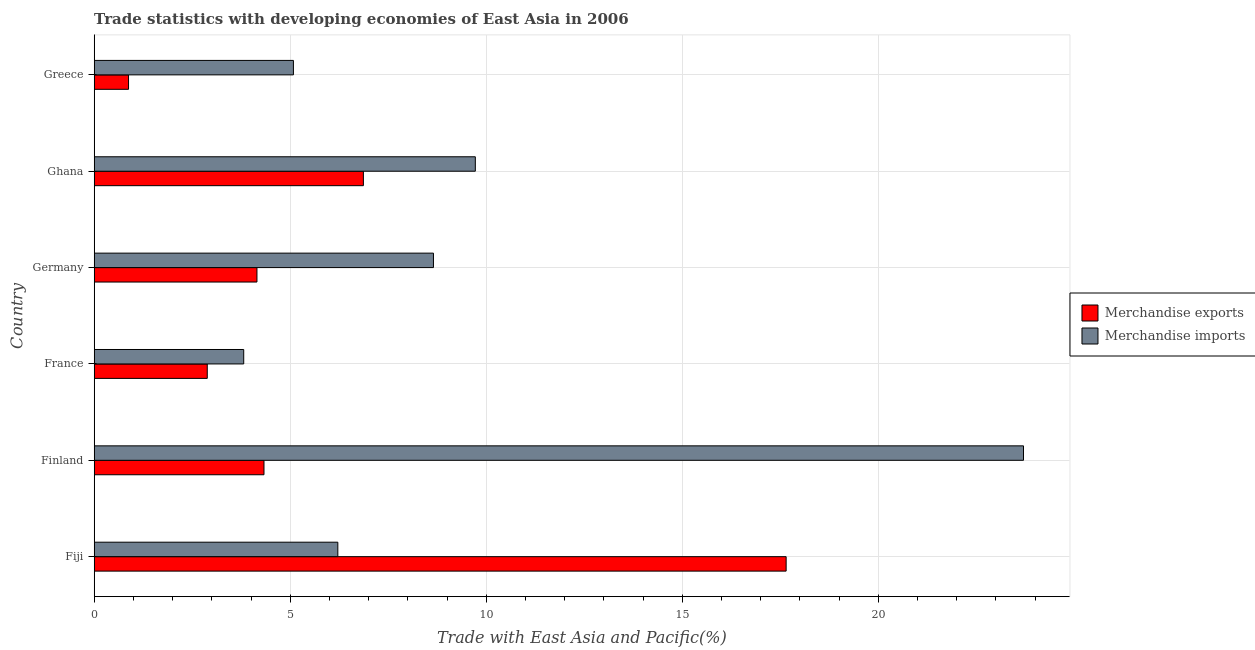How many different coloured bars are there?
Ensure brevity in your answer.  2. How many groups of bars are there?
Provide a succinct answer. 6. Are the number of bars per tick equal to the number of legend labels?
Give a very brief answer. Yes. Are the number of bars on each tick of the Y-axis equal?
Keep it short and to the point. Yes. What is the label of the 6th group of bars from the top?
Keep it short and to the point. Fiji. What is the merchandise exports in Germany?
Offer a very short reply. 4.15. Across all countries, what is the maximum merchandise exports?
Provide a short and direct response. 17.65. Across all countries, what is the minimum merchandise exports?
Provide a short and direct response. 0.88. In which country was the merchandise imports maximum?
Your answer should be compact. Finland. In which country was the merchandise imports minimum?
Your answer should be very brief. France. What is the total merchandise imports in the graph?
Keep it short and to the point. 57.18. What is the difference between the merchandise imports in Fiji and that in Finland?
Offer a terse response. -17.49. What is the difference between the merchandise exports in Finland and the merchandise imports in France?
Give a very brief answer. 0.52. What is the average merchandise exports per country?
Offer a very short reply. 6.13. What is the difference between the merchandise imports and merchandise exports in Greece?
Your answer should be very brief. 4.21. What is the ratio of the merchandise imports in France to that in Ghana?
Give a very brief answer. 0.39. Is the difference between the merchandise exports in Fiji and Germany greater than the difference between the merchandise imports in Fiji and Germany?
Your answer should be compact. Yes. What is the difference between the highest and the second highest merchandise imports?
Keep it short and to the point. 13.98. What is the difference between the highest and the lowest merchandise exports?
Ensure brevity in your answer.  16.77. In how many countries, is the merchandise imports greater than the average merchandise imports taken over all countries?
Your answer should be very brief. 2. Is the sum of the merchandise imports in Fiji and Finland greater than the maximum merchandise exports across all countries?
Give a very brief answer. Yes. How many bars are there?
Your answer should be very brief. 12. Are all the bars in the graph horizontal?
Your answer should be compact. Yes. Are the values on the major ticks of X-axis written in scientific E-notation?
Offer a terse response. No. Does the graph contain any zero values?
Your response must be concise. No. How many legend labels are there?
Offer a terse response. 2. How are the legend labels stacked?
Offer a very short reply. Vertical. What is the title of the graph?
Give a very brief answer. Trade statistics with developing economies of East Asia in 2006. What is the label or title of the X-axis?
Give a very brief answer. Trade with East Asia and Pacific(%). What is the label or title of the Y-axis?
Your answer should be compact. Country. What is the Trade with East Asia and Pacific(%) of Merchandise exports in Fiji?
Give a very brief answer. 17.65. What is the Trade with East Asia and Pacific(%) in Merchandise imports in Fiji?
Make the answer very short. 6.21. What is the Trade with East Asia and Pacific(%) in Merchandise exports in Finland?
Keep it short and to the point. 4.33. What is the Trade with East Asia and Pacific(%) of Merchandise imports in Finland?
Ensure brevity in your answer.  23.7. What is the Trade with East Asia and Pacific(%) of Merchandise exports in France?
Keep it short and to the point. 2.88. What is the Trade with East Asia and Pacific(%) of Merchandise imports in France?
Give a very brief answer. 3.81. What is the Trade with East Asia and Pacific(%) of Merchandise exports in Germany?
Provide a succinct answer. 4.15. What is the Trade with East Asia and Pacific(%) of Merchandise imports in Germany?
Make the answer very short. 8.65. What is the Trade with East Asia and Pacific(%) in Merchandise exports in Ghana?
Give a very brief answer. 6.87. What is the Trade with East Asia and Pacific(%) in Merchandise imports in Ghana?
Provide a short and direct response. 9.72. What is the Trade with East Asia and Pacific(%) in Merchandise exports in Greece?
Offer a terse response. 0.88. What is the Trade with East Asia and Pacific(%) of Merchandise imports in Greece?
Offer a terse response. 5.08. Across all countries, what is the maximum Trade with East Asia and Pacific(%) of Merchandise exports?
Your answer should be compact. 17.65. Across all countries, what is the maximum Trade with East Asia and Pacific(%) of Merchandise imports?
Make the answer very short. 23.7. Across all countries, what is the minimum Trade with East Asia and Pacific(%) in Merchandise exports?
Provide a succinct answer. 0.88. Across all countries, what is the minimum Trade with East Asia and Pacific(%) of Merchandise imports?
Ensure brevity in your answer.  3.81. What is the total Trade with East Asia and Pacific(%) in Merchandise exports in the graph?
Provide a short and direct response. 36.76. What is the total Trade with East Asia and Pacific(%) of Merchandise imports in the graph?
Offer a very short reply. 57.18. What is the difference between the Trade with East Asia and Pacific(%) of Merchandise exports in Fiji and that in Finland?
Make the answer very short. 13.32. What is the difference between the Trade with East Asia and Pacific(%) in Merchandise imports in Fiji and that in Finland?
Ensure brevity in your answer.  -17.49. What is the difference between the Trade with East Asia and Pacific(%) in Merchandise exports in Fiji and that in France?
Keep it short and to the point. 14.76. What is the difference between the Trade with East Asia and Pacific(%) of Merchandise imports in Fiji and that in France?
Ensure brevity in your answer.  2.4. What is the difference between the Trade with East Asia and Pacific(%) of Merchandise exports in Fiji and that in Germany?
Keep it short and to the point. 13.5. What is the difference between the Trade with East Asia and Pacific(%) in Merchandise imports in Fiji and that in Germany?
Offer a very short reply. -2.44. What is the difference between the Trade with East Asia and Pacific(%) in Merchandise exports in Fiji and that in Ghana?
Provide a succinct answer. 10.78. What is the difference between the Trade with East Asia and Pacific(%) in Merchandise imports in Fiji and that in Ghana?
Keep it short and to the point. -3.51. What is the difference between the Trade with East Asia and Pacific(%) in Merchandise exports in Fiji and that in Greece?
Your answer should be compact. 16.77. What is the difference between the Trade with East Asia and Pacific(%) of Merchandise imports in Fiji and that in Greece?
Keep it short and to the point. 1.13. What is the difference between the Trade with East Asia and Pacific(%) of Merchandise exports in Finland and that in France?
Give a very brief answer. 1.45. What is the difference between the Trade with East Asia and Pacific(%) of Merchandise imports in Finland and that in France?
Give a very brief answer. 19.89. What is the difference between the Trade with East Asia and Pacific(%) in Merchandise exports in Finland and that in Germany?
Keep it short and to the point. 0.18. What is the difference between the Trade with East Asia and Pacific(%) of Merchandise imports in Finland and that in Germany?
Keep it short and to the point. 15.05. What is the difference between the Trade with East Asia and Pacific(%) of Merchandise exports in Finland and that in Ghana?
Make the answer very short. -2.54. What is the difference between the Trade with East Asia and Pacific(%) of Merchandise imports in Finland and that in Ghana?
Keep it short and to the point. 13.98. What is the difference between the Trade with East Asia and Pacific(%) of Merchandise exports in Finland and that in Greece?
Keep it short and to the point. 3.45. What is the difference between the Trade with East Asia and Pacific(%) of Merchandise imports in Finland and that in Greece?
Ensure brevity in your answer.  18.62. What is the difference between the Trade with East Asia and Pacific(%) of Merchandise exports in France and that in Germany?
Make the answer very short. -1.27. What is the difference between the Trade with East Asia and Pacific(%) of Merchandise imports in France and that in Germany?
Provide a succinct answer. -4.84. What is the difference between the Trade with East Asia and Pacific(%) of Merchandise exports in France and that in Ghana?
Keep it short and to the point. -3.98. What is the difference between the Trade with East Asia and Pacific(%) in Merchandise imports in France and that in Ghana?
Your answer should be compact. -5.91. What is the difference between the Trade with East Asia and Pacific(%) of Merchandise exports in France and that in Greece?
Ensure brevity in your answer.  2.01. What is the difference between the Trade with East Asia and Pacific(%) of Merchandise imports in France and that in Greece?
Your answer should be very brief. -1.27. What is the difference between the Trade with East Asia and Pacific(%) of Merchandise exports in Germany and that in Ghana?
Keep it short and to the point. -2.71. What is the difference between the Trade with East Asia and Pacific(%) in Merchandise imports in Germany and that in Ghana?
Offer a terse response. -1.07. What is the difference between the Trade with East Asia and Pacific(%) of Merchandise exports in Germany and that in Greece?
Offer a terse response. 3.28. What is the difference between the Trade with East Asia and Pacific(%) of Merchandise imports in Germany and that in Greece?
Make the answer very short. 3.57. What is the difference between the Trade with East Asia and Pacific(%) in Merchandise exports in Ghana and that in Greece?
Offer a very short reply. 5.99. What is the difference between the Trade with East Asia and Pacific(%) of Merchandise imports in Ghana and that in Greece?
Keep it short and to the point. 4.64. What is the difference between the Trade with East Asia and Pacific(%) in Merchandise exports in Fiji and the Trade with East Asia and Pacific(%) in Merchandise imports in Finland?
Keep it short and to the point. -6.05. What is the difference between the Trade with East Asia and Pacific(%) in Merchandise exports in Fiji and the Trade with East Asia and Pacific(%) in Merchandise imports in France?
Offer a terse response. 13.83. What is the difference between the Trade with East Asia and Pacific(%) of Merchandise exports in Fiji and the Trade with East Asia and Pacific(%) of Merchandise imports in Germany?
Offer a very short reply. 9. What is the difference between the Trade with East Asia and Pacific(%) in Merchandise exports in Fiji and the Trade with East Asia and Pacific(%) in Merchandise imports in Ghana?
Provide a succinct answer. 7.93. What is the difference between the Trade with East Asia and Pacific(%) of Merchandise exports in Fiji and the Trade with East Asia and Pacific(%) of Merchandise imports in Greece?
Keep it short and to the point. 12.57. What is the difference between the Trade with East Asia and Pacific(%) in Merchandise exports in Finland and the Trade with East Asia and Pacific(%) in Merchandise imports in France?
Give a very brief answer. 0.52. What is the difference between the Trade with East Asia and Pacific(%) of Merchandise exports in Finland and the Trade with East Asia and Pacific(%) of Merchandise imports in Germany?
Offer a terse response. -4.32. What is the difference between the Trade with East Asia and Pacific(%) in Merchandise exports in Finland and the Trade with East Asia and Pacific(%) in Merchandise imports in Ghana?
Ensure brevity in your answer.  -5.39. What is the difference between the Trade with East Asia and Pacific(%) in Merchandise exports in Finland and the Trade with East Asia and Pacific(%) in Merchandise imports in Greece?
Ensure brevity in your answer.  -0.75. What is the difference between the Trade with East Asia and Pacific(%) of Merchandise exports in France and the Trade with East Asia and Pacific(%) of Merchandise imports in Germany?
Your answer should be very brief. -5.77. What is the difference between the Trade with East Asia and Pacific(%) of Merchandise exports in France and the Trade with East Asia and Pacific(%) of Merchandise imports in Ghana?
Provide a short and direct response. -6.84. What is the difference between the Trade with East Asia and Pacific(%) in Merchandise exports in France and the Trade with East Asia and Pacific(%) in Merchandise imports in Greece?
Offer a terse response. -2.2. What is the difference between the Trade with East Asia and Pacific(%) of Merchandise exports in Germany and the Trade with East Asia and Pacific(%) of Merchandise imports in Ghana?
Your answer should be very brief. -5.57. What is the difference between the Trade with East Asia and Pacific(%) of Merchandise exports in Germany and the Trade with East Asia and Pacific(%) of Merchandise imports in Greece?
Make the answer very short. -0.93. What is the difference between the Trade with East Asia and Pacific(%) in Merchandise exports in Ghana and the Trade with East Asia and Pacific(%) in Merchandise imports in Greece?
Provide a short and direct response. 1.78. What is the average Trade with East Asia and Pacific(%) of Merchandise exports per country?
Keep it short and to the point. 6.13. What is the average Trade with East Asia and Pacific(%) in Merchandise imports per country?
Offer a terse response. 9.53. What is the difference between the Trade with East Asia and Pacific(%) in Merchandise exports and Trade with East Asia and Pacific(%) in Merchandise imports in Fiji?
Provide a short and direct response. 11.43. What is the difference between the Trade with East Asia and Pacific(%) of Merchandise exports and Trade with East Asia and Pacific(%) of Merchandise imports in Finland?
Provide a succinct answer. -19.37. What is the difference between the Trade with East Asia and Pacific(%) of Merchandise exports and Trade with East Asia and Pacific(%) of Merchandise imports in France?
Provide a short and direct response. -0.93. What is the difference between the Trade with East Asia and Pacific(%) in Merchandise exports and Trade with East Asia and Pacific(%) in Merchandise imports in Germany?
Offer a very short reply. -4.5. What is the difference between the Trade with East Asia and Pacific(%) in Merchandise exports and Trade with East Asia and Pacific(%) in Merchandise imports in Ghana?
Provide a succinct answer. -2.85. What is the difference between the Trade with East Asia and Pacific(%) of Merchandise exports and Trade with East Asia and Pacific(%) of Merchandise imports in Greece?
Offer a very short reply. -4.21. What is the ratio of the Trade with East Asia and Pacific(%) of Merchandise exports in Fiji to that in Finland?
Provide a succinct answer. 4.08. What is the ratio of the Trade with East Asia and Pacific(%) of Merchandise imports in Fiji to that in Finland?
Provide a succinct answer. 0.26. What is the ratio of the Trade with East Asia and Pacific(%) of Merchandise exports in Fiji to that in France?
Provide a short and direct response. 6.12. What is the ratio of the Trade with East Asia and Pacific(%) of Merchandise imports in Fiji to that in France?
Offer a very short reply. 1.63. What is the ratio of the Trade with East Asia and Pacific(%) of Merchandise exports in Fiji to that in Germany?
Your answer should be compact. 4.25. What is the ratio of the Trade with East Asia and Pacific(%) in Merchandise imports in Fiji to that in Germany?
Offer a very short reply. 0.72. What is the ratio of the Trade with East Asia and Pacific(%) of Merchandise exports in Fiji to that in Ghana?
Give a very brief answer. 2.57. What is the ratio of the Trade with East Asia and Pacific(%) in Merchandise imports in Fiji to that in Ghana?
Your response must be concise. 0.64. What is the ratio of the Trade with East Asia and Pacific(%) in Merchandise exports in Fiji to that in Greece?
Your answer should be very brief. 20.15. What is the ratio of the Trade with East Asia and Pacific(%) in Merchandise imports in Fiji to that in Greece?
Ensure brevity in your answer.  1.22. What is the ratio of the Trade with East Asia and Pacific(%) in Merchandise exports in Finland to that in France?
Give a very brief answer. 1.5. What is the ratio of the Trade with East Asia and Pacific(%) of Merchandise imports in Finland to that in France?
Your answer should be very brief. 6.22. What is the ratio of the Trade with East Asia and Pacific(%) in Merchandise exports in Finland to that in Germany?
Offer a very short reply. 1.04. What is the ratio of the Trade with East Asia and Pacific(%) of Merchandise imports in Finland to that in Germany?
Make the answer very short. 2.74. What is the ratio of the Trade with East Asia and Pacific(%) in Merchandise exports in Finland to that in Ghana?
Your response must be concise. 0.63. What is the ratio of the Trade with East Asia and Pacific(%) of Merchandise imports in Finland to that in Ghana?
Keep it short and to the point. 2.44. What is the ratio of the Trade with East Asia and Pacific(%) of Merchandise exports in Finland to that in Greece?
Ensure brevity in your answer.  4.94. What is the ratio of the Trade with East Asia and Pacific(%) in Merchandise imports in Finland to that in Greece?
Provide a short and direct response. 4.66. What is the ratio of the Trade with East Asia and Pacific(%) of Merchandise exports in France to that in Germany?
Keep it short and to the point. 0.69. What is the ratio of the Trade with East Asia and Pacific(%) of Merchandise imports in France to that in Germany?
Your answer should be compact. 0.44. What is the ratio of the Trade with East Asia and Pacific(%) in Merchandise exports in France to that in Ghana?
Offer a terse response. 0.42. What is the ratio of the Trade with East Asia and Pacific(%) in Merchandise imports in France to that in Ghana?
Give a very brief answer. 0.39. What is the ratio of the Trade with East Asia and Pacific(%) in Merchandise exports in France to that in Greece?
Make the answer very short. 3.29. What is the ratio of the Trade with East Asia and Pacific(%) in Merchandise imports in France to that in Greece?
Your answer should be very brief. 0.75. What is the ratio of the Trade with East Asia and Pacific(%) of Merchandise exports in Germany to that in Ghana?
Keep it short and to the point. 0.6. What is the ratio of the Trade with East Asia and Pacific(%) of Merchandise imports in Germany to that in Ghana?
Offer a terse response. 0.89. What is the ratio of the Trade with East Asia and Pacific(%) of Merchandise exports in Germany to that in Greece?
Provide a short and direct response. 4.74. What is the ratio of the Trade with East Asia and Pacific(%) in Merchandise imports in Germany to that in Greece?
Offer a very short reply. 1.7. What is the ratio of the Trade with East Asia and Pacific(%) in Merchandise exports in Ghana to that in Greece?
Your answer should be compact. 7.84. What is the ratio of the Trade with East Asia and Pacific(%) of Merchandise imports in Ghana to that in Greece?
Your response must be concise. 1.91. What is the difference between the highest and the second highest Trade with East Asia and Pacific(%) in Merchandise exports?
Your response must be concise. 10.78. What is the difference between the highest and the second highest Trade with East Asia and Pacific(%) in Merchandise imports?
Ensure brevity in your answer.  13.98. What is the difference between the highest and the lowest Trade with East Asia and Pacific(%) in Merchandise exports?
Give a very brief answer. 16.77. What is the difference between the highest and the lowest Trade with East Asia and Pacific(%) of Merchandise imports?
Ensure brevity in your answer.  19.89. 